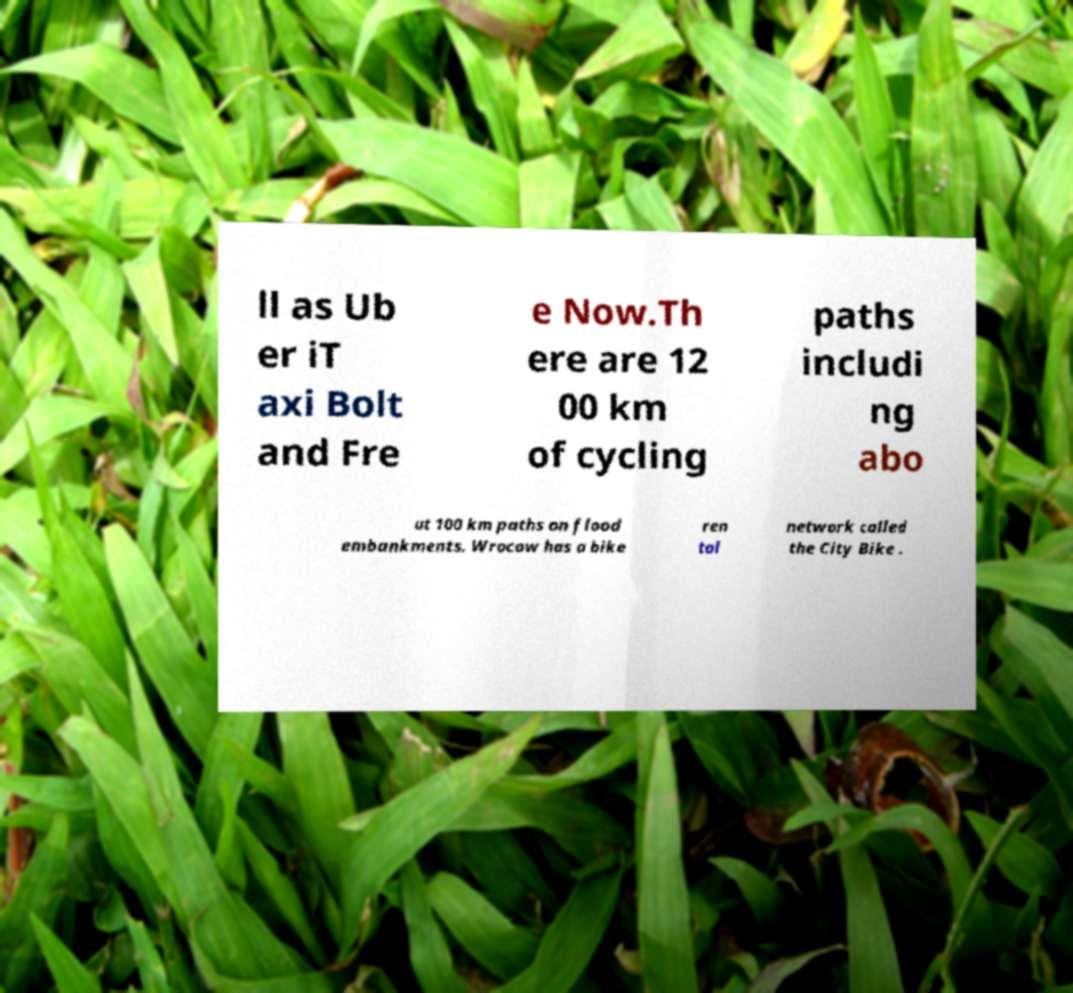There's text embedded in this image that I need extracted. Can you transcribe it verbatim? ll as Ub er iT axi Bolt and Fre e Now.Th ere are 12 00 km of cycling paths includi ng abo ut 100 km paths on flood embankments. Wrocaw has a bike ren tal network called the City Bike . 